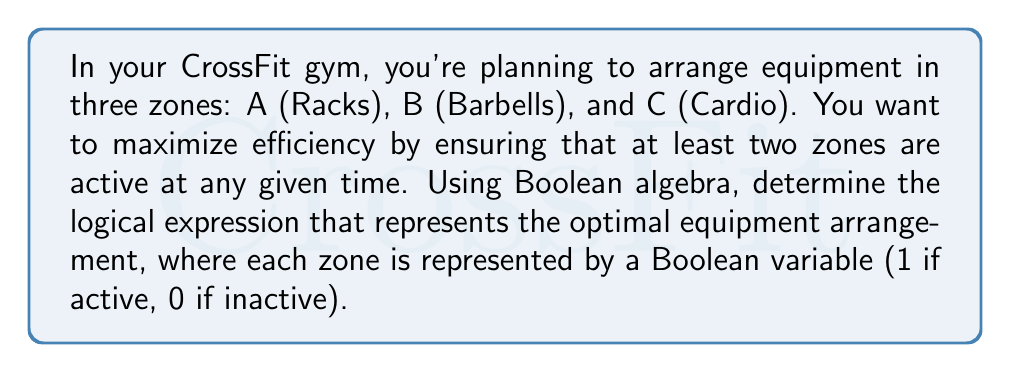Teach me how to tackle this problem. Let's approach this step-by-step using Boolean algebra:

1) We need at least two zones to be active at any given time. This means we want to avoid the situation where only one zone or no zones are active.

2) Let's first express the situations we want to avoid:
   - No zones active: $\overline{A} \cdot \overline{B} \cdot \overline{C}$
   - Only A active: $A \cdot \overline{B} \cdot \overline{C}$
   - Only B active: $\overline{A} \cdot B \cdot \overline{C}$
   - Only C active: $\overline{A} \cdot \overline{B} \cdot C$

3) The optimal arrangement is the negation of these undesired situations. Let's call our optimal function $F$:

   $$F = \overline{(\overline{A} \cdot \overline{B} \cdot \overline{C} + A \cdot \overline{B} \cdot \overline{C} + \overline{A} \cdot B \cdot \overline{C} + \overline{A} \cdot \overline{B} \cdot C)}$$

4) Using De Morgan's law, we can simplify this:

   $$F = (A + B + C) \cdot (\overline{A} + B + C) \cdot (A + \overline{B} + C) \cdot (A + B + \overline{C})$$

5) This expression represents the optimal arrangement: at least two zones must be active at any time.

6) We can further simplify this using Boolean algebra laws:

   $$F = (A + B) \cdot (A + C) \cdot (B + C)$$

This final expression represents the most efficient equipment arrangement in Boolean terms.
Answer: $(A + B) \cdot (A + C) \cdot (B + C)$ 